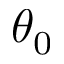<formula> <loc_0><loc_0><loc_500><loc_500>\theta _ { 0 }</formula> 